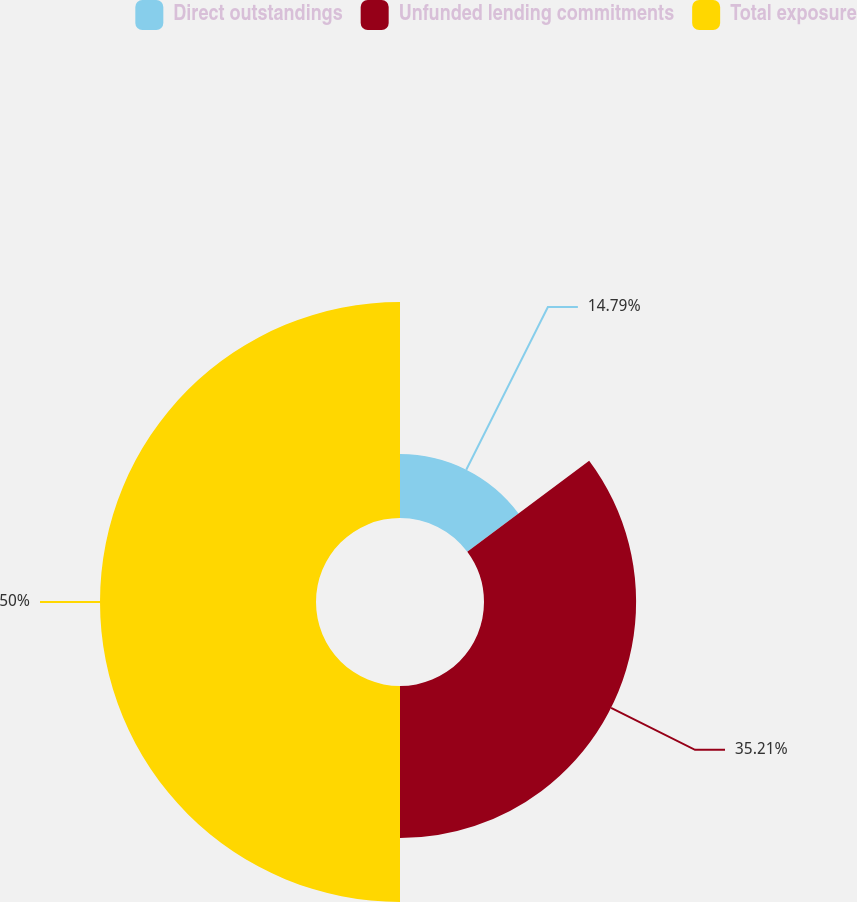Convert chart. <chart><loc_0><loc_0><loc_500><loc_500><pie_chart><fcel>Direct outstandings<fcel>Unfunded lending commitments<fcel>Total exposure<nl><fcel>14.79%<fcel>35.21%<fcel>50.0%<nl></chart> 